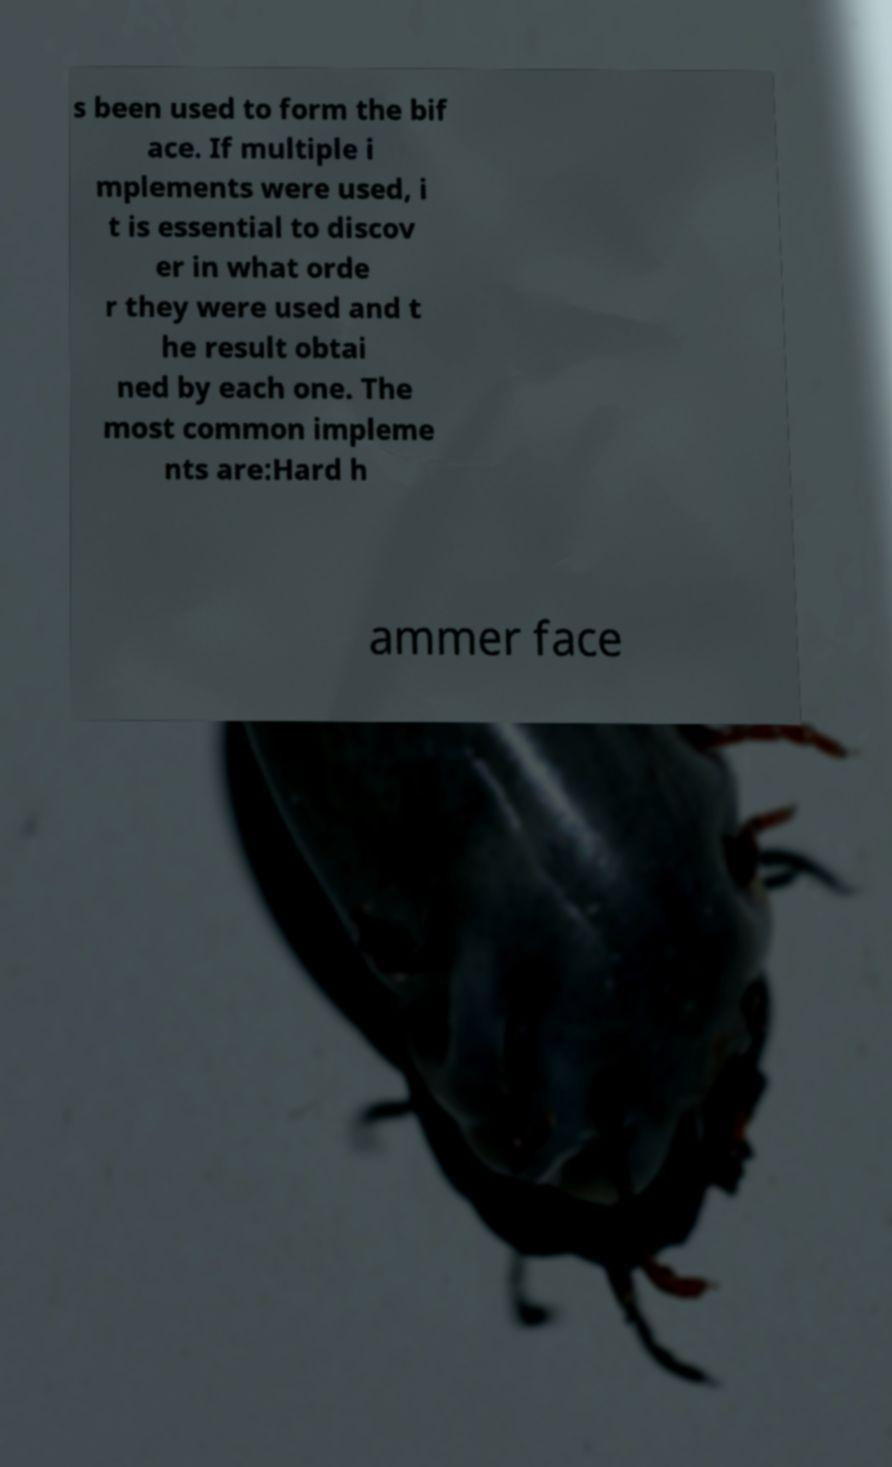Can you accurately transcribe the text from the provided image for me? s been used to form the bif ace. If multiple i mplements were used, i t is essential to discov er in what orde r they were used and t he result obtai ned by each one. The most common impleme nts are:Hard h ammer face 